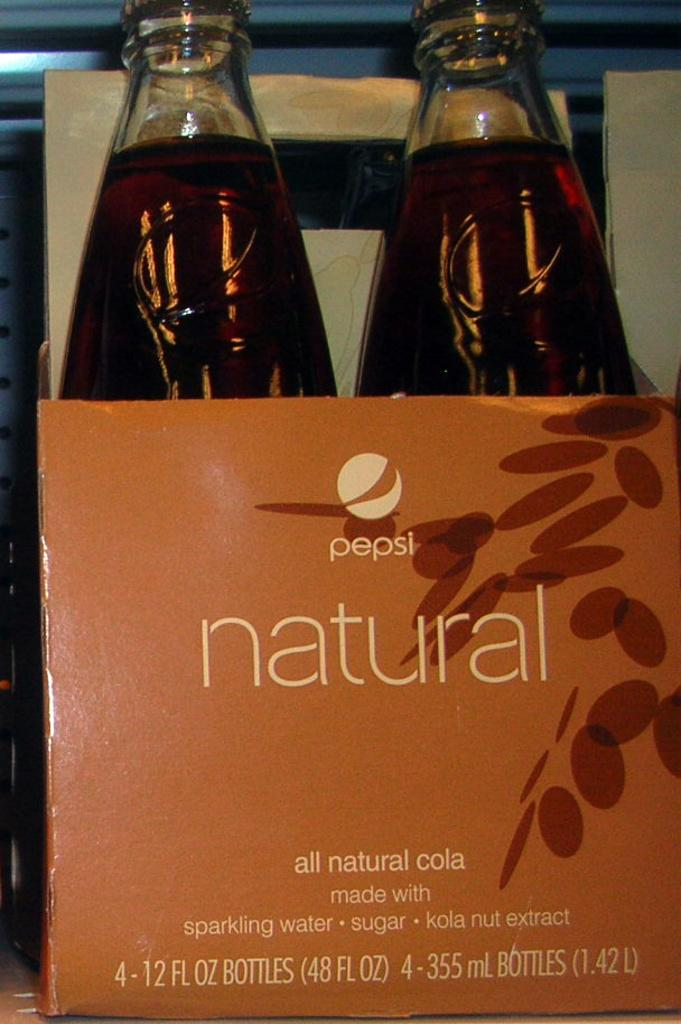<image>
Summarize the visual content of the image. Two bottle of soda, that has a label on it called Pepsi. 